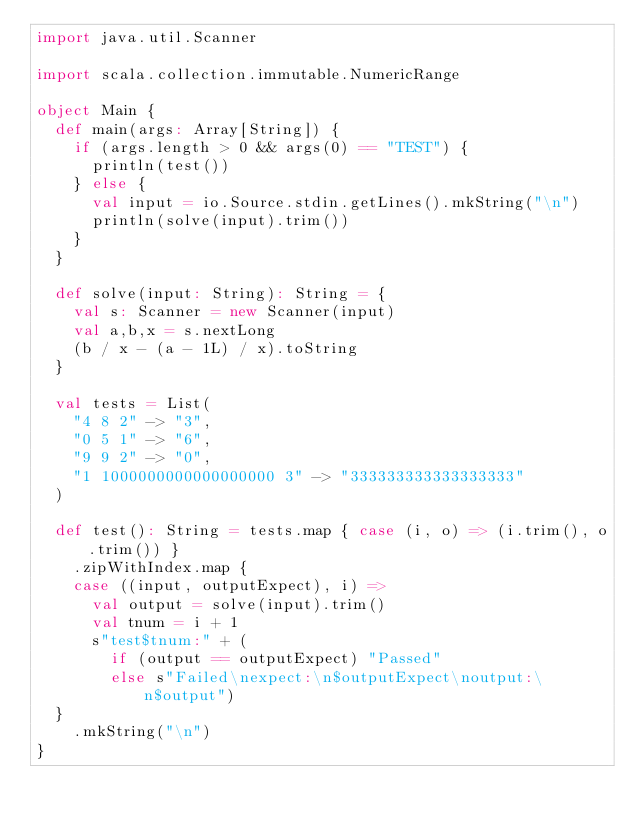Convert code to text. <code><loc_0><loc_0><loc_500><loc_500><_Scala_>import java.util.Scanner

import scala.collection.immutable.NumericRange

object Main {
  def main(args: Array[String]) {
    if (args.length > 0 && args(0) == "TEST") {
      println(test())
    } else {
      val input = io.Source.stdin.getLines().mkString("\n")
      println(solve(input).trim())
    }
  }

  def solve(input: String): String = {
    val s: Scanner = new Scanner(input)
    val a,b,x = s.nextLong
    (b / x - (a - 1L) / x).toString
  }

  val tests = List(
    "4 8 2" -> "3",
    "0 5 1" -> "6",
    "9 9 2" -> "0",
    "1 1000000000000000000 3" -> "333333333333333333"
  )

  def test(): String = tests.map { case (i, o) => (i.trim(), o.trim()) }
    .zipWithIndex.map {
    case ((input, outputExpect), i) =>
      val output = solve(input).trim()
      val tnum = i + 1
      s"test$tnum:" + (
        if (output == outputExpect) "Passed"
        else s"Failed\nexpect:\n$outputExpect\noutput:\n$output")
  }
    .mkString("\n")
}</code> 